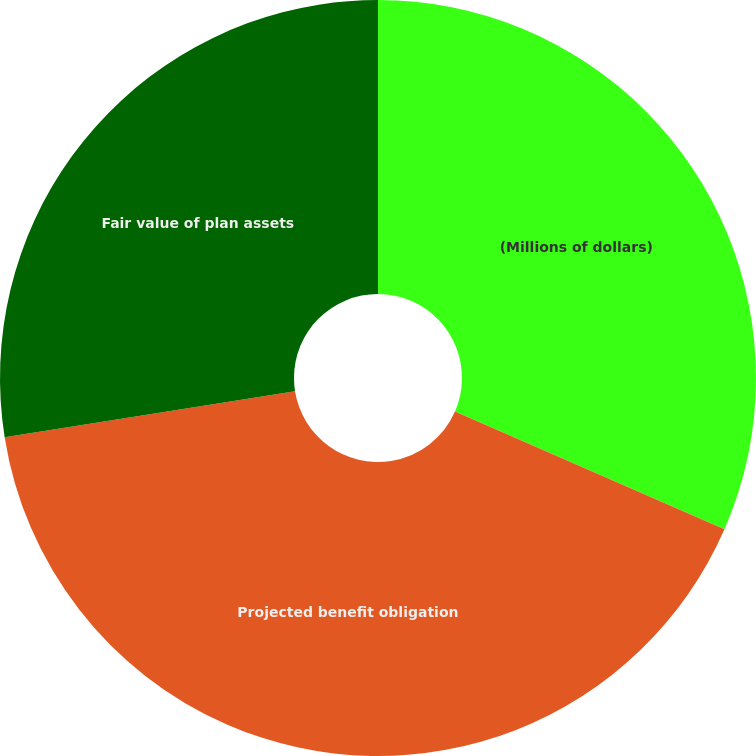Convert chart to OTSL. <chart><loc_0><loc_0><loc_500><loc_500><pie_chart><fcel>(Millions of dollars)<fcel>Projected benefit obligation<fcel>Fair value of plan assets<nl><fcel>31.55%<fcel>40.95%<fcel>27.5%<nl></chart> 